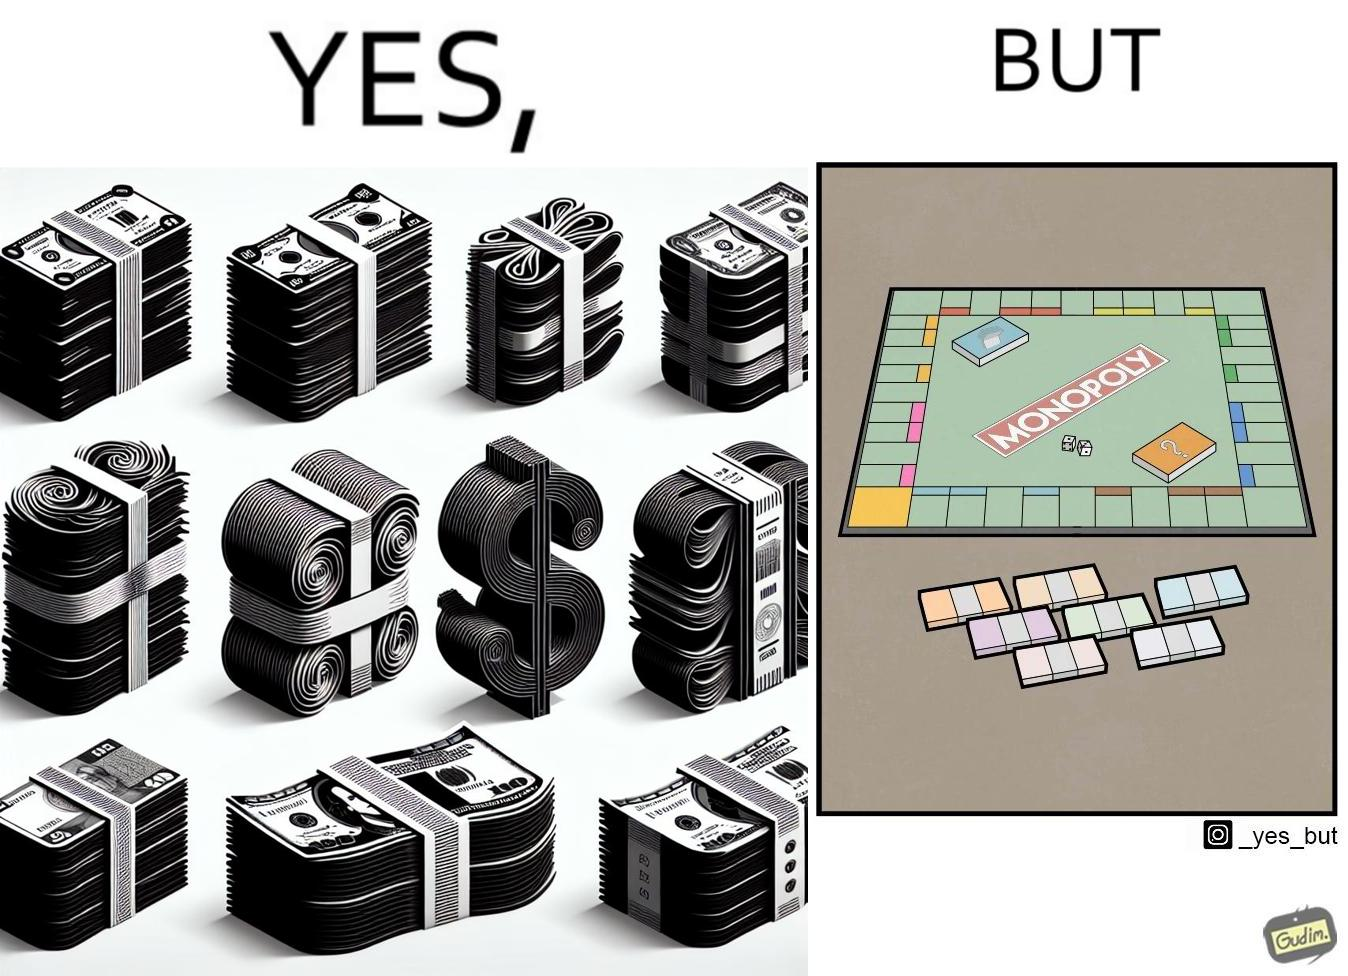Provide a description of this image. The image is ironic, because there are many different color currency notes' bundles but they are just as a currency in the game of monopoly and they have no real value 